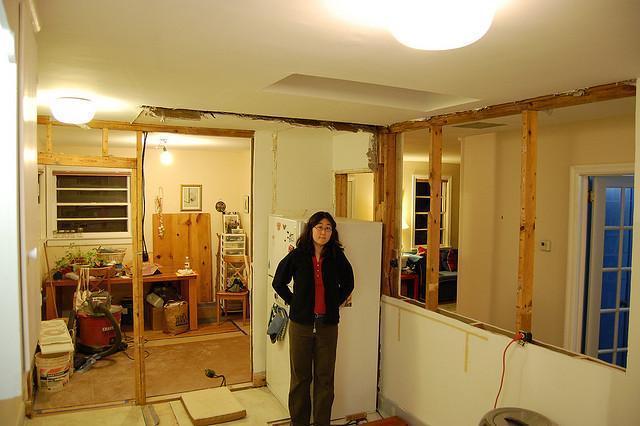How many lights are there?
Give a very brief answer. 3. 